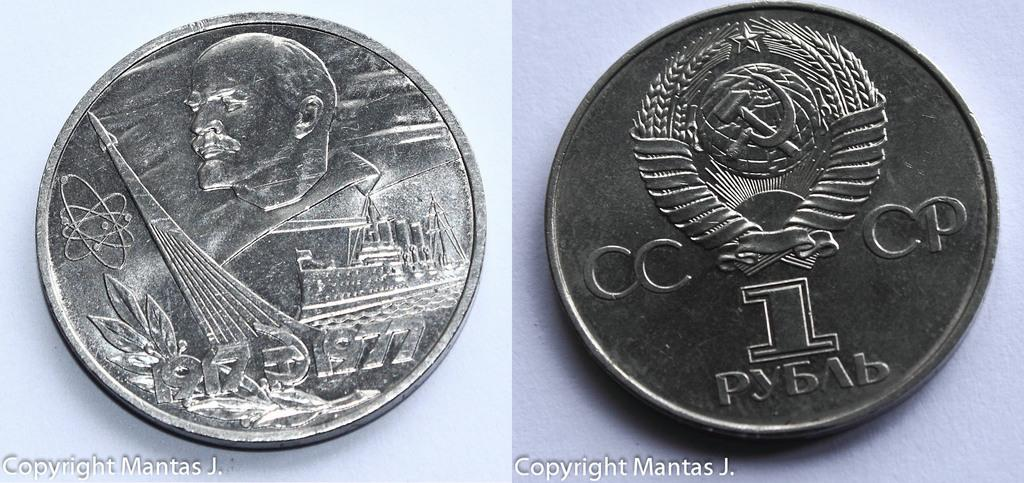<image>
Describe the image concisely. One side of a coin has the letters CCCP written on it. 